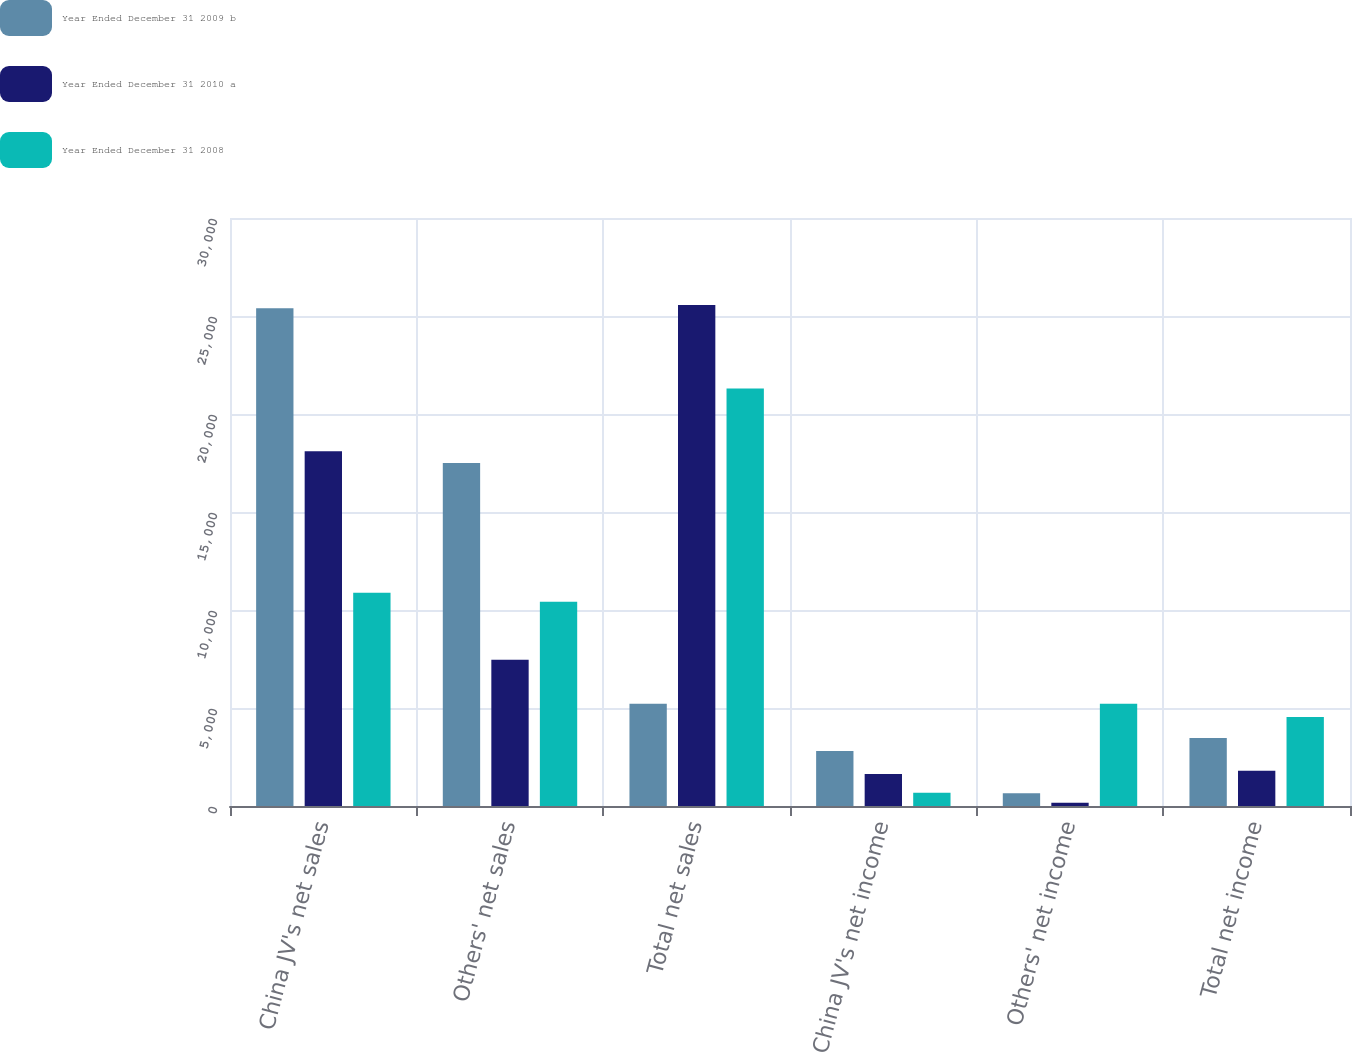Convert chart to OTSL. <chart><loc_0><loc_0><loc_500><loc_500><stacked_bar_chart><ecel><fcel>China JV's net sales<fcel>Others' net sales<fcel>Total net sales<fcel>China JV's net income<fcel>Others' net income<fcel>Total net income<nl><fcel>Year Ended December 31 2009 b<fcel>25395<fcel>17500<fcel>5212<fcel>2808<fcel>656<fcel>3464<nl><fcel>Year Ended December 31 2010 a<fcel>18098<fcel>7457<fcel>25555<fcel>1636<fcel>161<fcel>1797<nl><fcel>Year Ended December 31 2008<fcel>10883<fcel>10415<fcel>21298<fcel>671<fcel>5212<fcel>4541<nl></chart> 